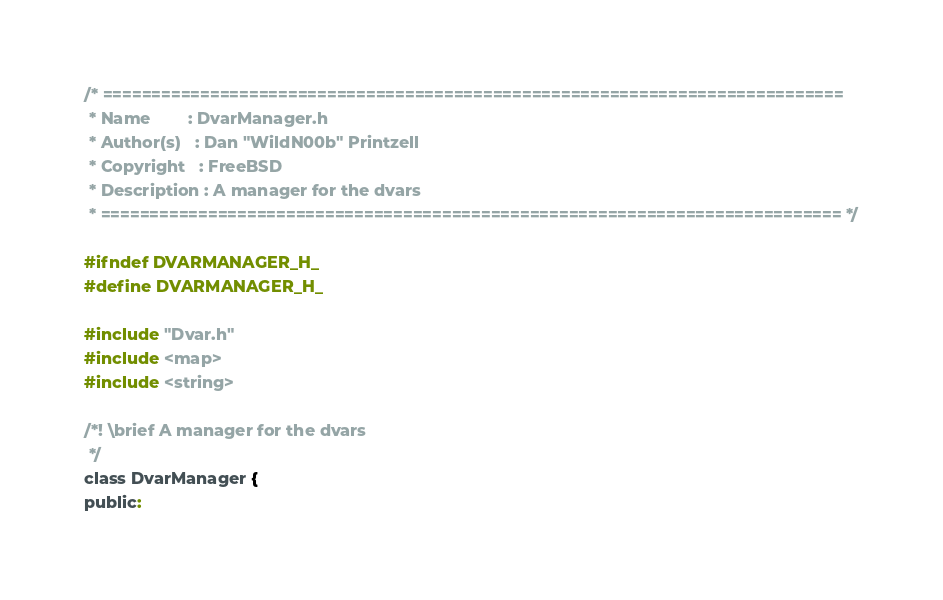<code> <loc_0><loc_0><loc_500><loc_500><_C_>/* ============================================================================
 * Name        : DvarManager.h
 * Author(s)   : Dan "WildN00b" Printzell
 * Copyright   : FreeBSD
 * Description : A manager for the dvars
 * ============================================================================ */

#ifndef DVARMANAGER_H_
#define DVARMANAGER_H_

#include "Dvar.h"
#include <map>
#include <string>

/*! \brief A manager for the dvars
 */
class DvarManager {
public:</code> 